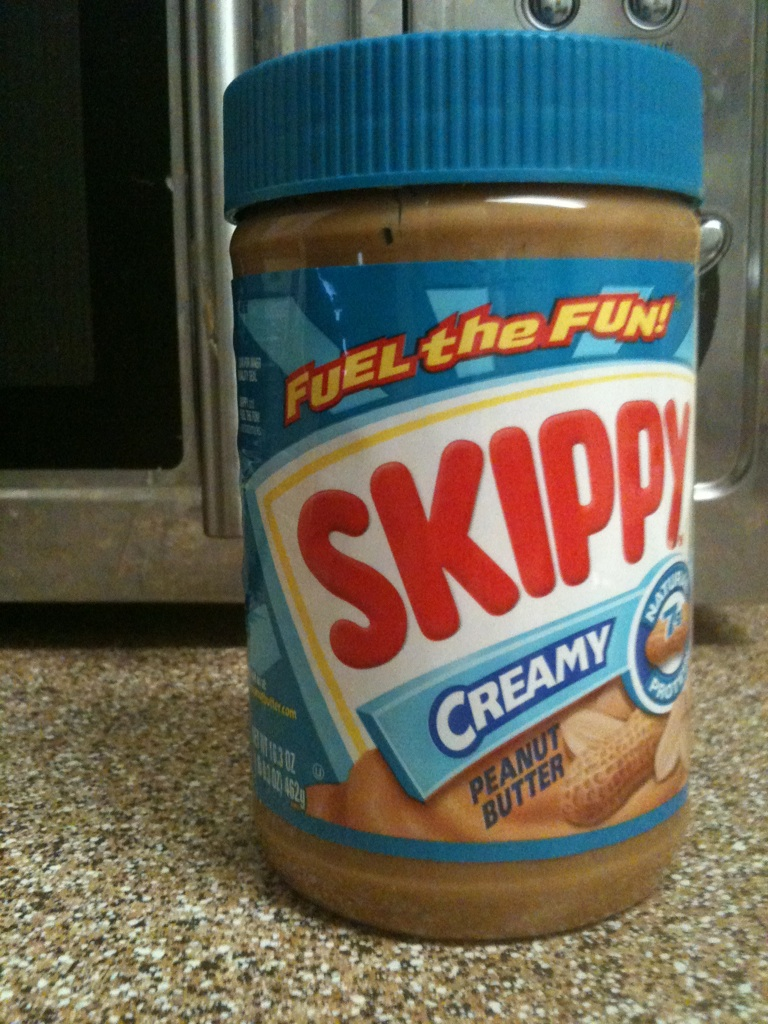What brand of peanut butter is this? The peanut butter shown in the image is the 'Skippy' brand, specifically their Creamy peanut butter variety. Skippy has been a popular choice in many households, known for its rich flavor and smooth texture. 